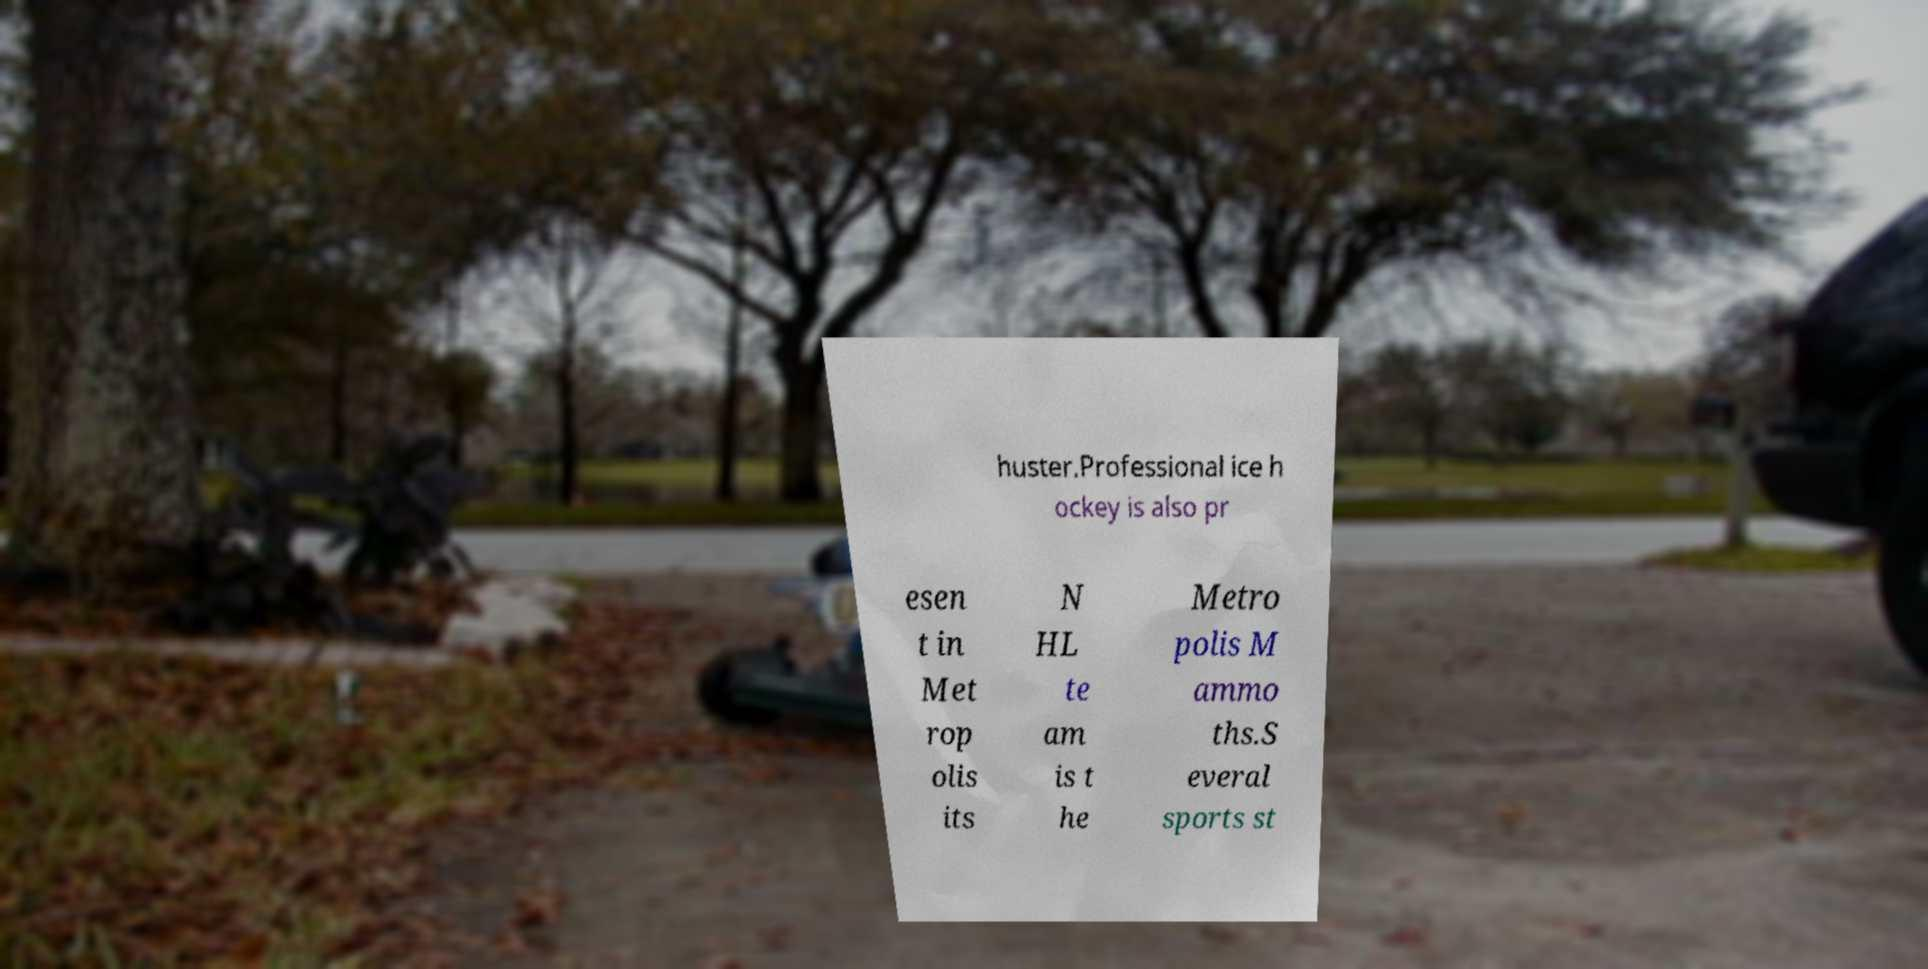Could you extract and type out the text from this image? huster.Professional ice h ockey is also pr esen t in Met rop olis its N HL te am is t he Metro polis M ammo ths.S everal sports st 